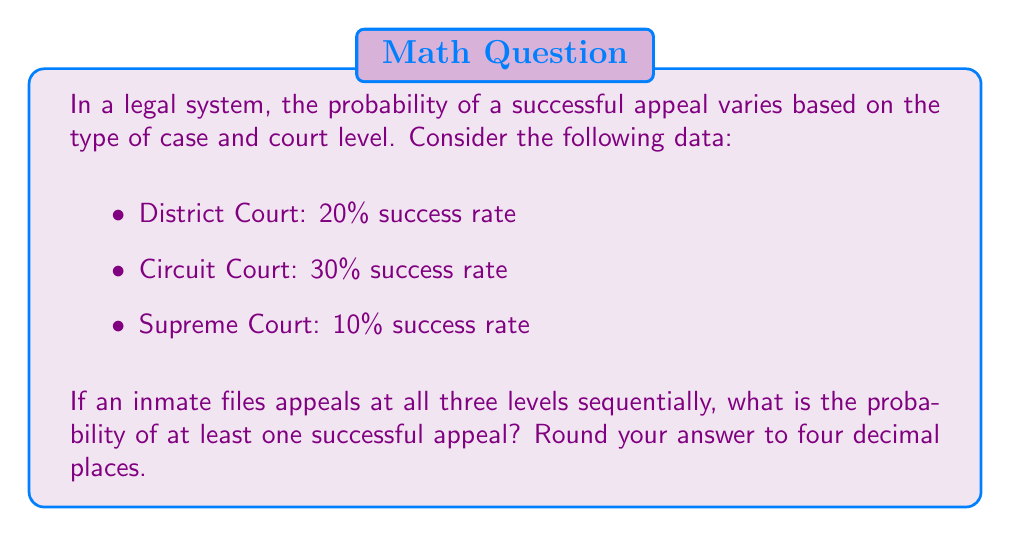Can you solve this math problem? Let's approach this step-by-step:

1) First, we need to calculate the probability of failure at each level:
   - District Court: $1 - 0.20 = 0.80$
   - Circuit Court: $1 - 0.30 = 0.70$
   - Supreme Court: $1 - 0.10 = 0.90$

2) The probability of all appeals failing is the product of these individual probabilities:
   $P(\text{all fail}) = 0.80 \times 0.70 \times 0.90 = 0.504$

3) Therefore, the probability of at least one appeal succeeding is the complement of all appeals failing:
   $P(\text{at least one succeeds}) = 1 - P(\text{all fail})$
   $= 1 - 0.504 = 0.496$

4) Rounding to four decimal places:
   $0.496 \approx 0.4960$

This result indicates that there's approximately a 49.60% chance of at least one appeal being successful when pursuing all three levels of the court system.
Answer: $0.4960$ 